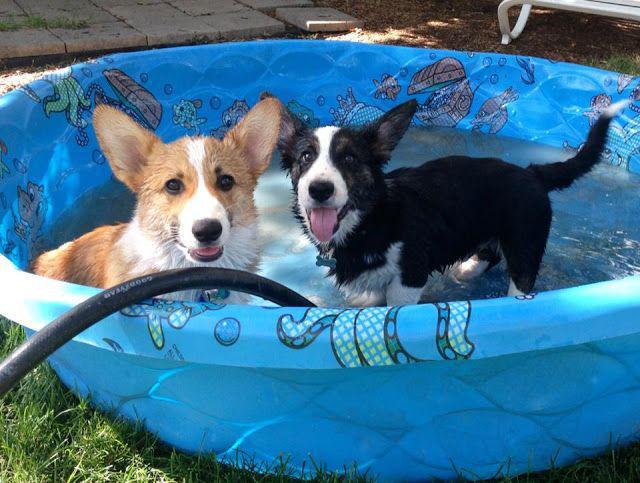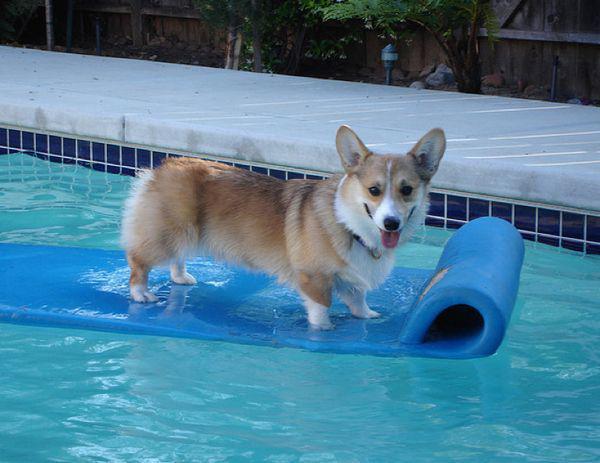The first image is the image on the left, the second image is the image on the right. Evaluate the accuracy of this statement regarding the images: "In one image there is a corgi riding on a raft in a pool and the other shows at least one dog in a kiddie pool.". Is it true? Answer yes or no. Yes. 